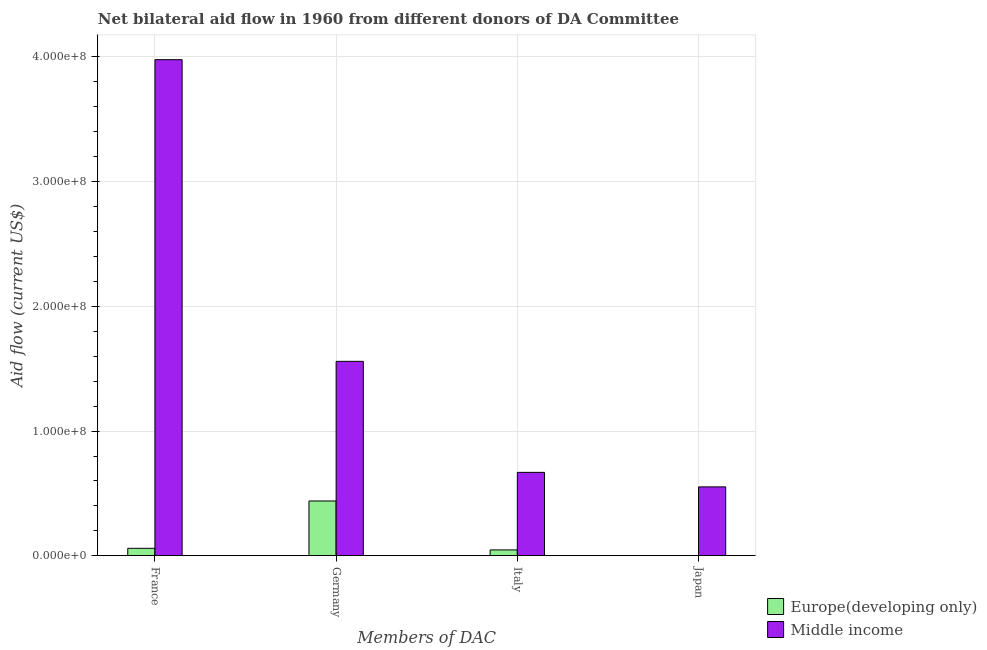How many different coloured bars are there?
Provide a short and direct response. 2. How many groups of bars are there?
Your answer should be compact. 4. Are the number of bars per tick equal to the number of legend labels?
Give a very brief answer. Yes. Are the number of bars on each tick of the X-axis equal?
Make the answer very short. Yes. What is the label of the 2nd group of bars from the left?
Provide a succinct answer. Germany. What is the amount of aid given by germany in Middle income?
Keep it short and to the point. 1.56e+08. Across all countries, what is the maximum amount of aid given by germany?
Ensure brevity in your answer.  1.56e+08. Across all countries, what is the minimum amount of aid given by italy?
Offer a very short reply. 4.71e+06. In which country was the amount of aid given by italy maximum?
Provide a succinct answer. Middle income. In which country was the amount of aid given by france minimum?
Provide a succinct answer. Europe(developing only). What is the total amount of aid given by japan in the graph?
Provide a succinct answer. 5.53e+07. What is the difference between the amount of aid given by france in Middle income and that in Europe(developing only)?
Your answer should be very brief. 3.92e+08. What is the difference between the amount of aid given by japan in Middle income and the amount of aid given by germany in Europe(developing only)?
Make the answer very short. 1.13e+07. What is the average amount of aid given by france per country?
Your answer should be very brief. 2.02e+08. What is the difference between the amount of aid given by italy and amount of aid given by france in Middle income?
Offer a terse response. -3.31e+08. What is the ratio of the amount of aid given by germany in Europe(developing only) to that in Middle income?
Your response must be concise. 0.28. What is the difference between the highest and the second highest amount of aid given by france?
Keep it short and to the point. 3.92e+08. What is the difference between the highest and the lowest amount of aid given by france?
Your answer should be compact. 3.92e+08. Is the sum of the amount of aid given by japan in Europe(developing only) and Middle income greater than the maximum amount of aid given by italy across all countries?
Your answer should be very brief. No. Is it the case that in every country, the sum of the amount of aid given by france and amount of aid given by italy is greater than the sum of amount of aid given by germany and amount of aid given by japan?
Make the answer very short. No. What does the 1st bar from the left in Italy represents?
Ensure brevity in your answer.  Europe(developing only). What does the 2nd bar from the right in Japan represents?
Your response must be concise. Europe(developing only). How many bars are there?
Offer a very short reply. 8. How many countries are there in the graph?
Offer a very short reply. 2. Are the values on the major ticks of Y-axis written in scientific E-notation?
Make the answer very short. Yes. Does the graph contain any zero values?
Give a very brief answer. No. Does the graph contain grids?
Offer a terse response. Yes. Where does the legend appear in the graph?
Your answer should be very brief. Bottom right. What is the title of the graph?
Give a very brief answer. Net bilateral aid flow in 1960 from different donors of DA Committee. What is the label or title of the X-axis?
Offer a very short reply. Members of DAC. What is the label or title of the Y-axis?
Offer a terse response. Aid flow (current US$). What is the Aid flow (current US$) of Europe(developing only) in France?
Make the answer very short. 6.00e+06. What is the Aid flow (current US$) of Middle income in France?
Make the answer very short. 3.98e+08. What is the Aid flow (current US$) of Europe(developing only) in Germany?
Ensure brevity in your answer.  4.40e+07. What is the Aid flow (current US$) of Middle income in Germany?
Give a very brief answer. 1.56e+08. What is the Aid flow (current US$) in Europe(developing only) in Italy?
Offer a terse response. 4.71e+06. What is the Aid flow (current US$) in Middle income in Italy?
Give a very brief answer. 6.69e+07. What is the Aid flow (current US$) in Europe(developing only) in Japan?
Give a very brief answer. 10000. What is the Aid flow (current US$) of Middle income in Japan?
Give a very brief answer. 5.53e+07. Across all Members of DAC, what is the maximum Aid flow (current US$) of Europe(developing only)?
Keep it short and to the point. 4.40e+07. Across all Members of DAC, what is the maximum Aid flow (current US$) of Middle income?
Your response must be concise. 3.98e+08. Across all Members of DAC, what is the minimum Aid flow (current US$) in Middle income?
Your response must be concise. 5.53e+07. What is the total Aid flow (current US$) in Europe(developing only) in the graph?
Your response must be concise. 5.47e+07. What is the total Aid flow (current US$) in Middle income in the graph?
Offer a very short reply. 6.76e+08. What is the difference between the Aid flow (current US$) of Europe(developing only) in France and that in Germany?
Give a very brief answer. -3.80e+07. What is the difference between the Aid flow (current US$) in Middle income in France and that in Germany?
Offer a very short reply. 2.42e+08. What is the difference between the Aid flow (current US$) in Europe(developing only) in France and that in Italy?
Ensure brevity in your answer.  1.29e+06. What is the difference between the Aid flow (current US$) in Middle income in France and that in Italy?
Ensure brevity in your answer.  3.31e+08. What is the difference between the Aid flow (current US$) in Europe(developing only) in France and that in Japan?
Your answer should be very brief. 5.99e+06. What is the difference between the Aid flow (current US$) of Middle income in France and that in Japan?
Provide a short and direct response. 3.43e+08. What is the difference between the Aid flow (current US$) in Europe(developing only) in Germany and that in Italy?
Offer a very short reply. 3.92e+07. What is the difference between the Aid flow (current US$) in Middle income in Germany and that in Italy?
Offer a very short reply. 8.90e+07. What is the difference between the Aid flow (current US$) in Europe(developing only) in Germany and that in Japan?
Ensure brevity in your answer.  4.40e+07. What is the difference between the Aid flow (current US$) in Middle income in Germany and that in Japan?
Make the answer very short. 1.01e+08. What is the difference between the Aid flow (current US$) in Europe(developing only) in Italy and that in Japan?
Your answer should be very brief. 4.70e+06. What is the difference between the Aid flow (current US$) in Middle income in Italy and that in Japan?
Make the answer very short. 1.16e+07. What is the difference between the Aid flow (current US$) of Europe(developing only) in France and the Aid flow (current US$) of Middle income in Germany?
Provide a succinct answer. -1.50e+08. What is the difference between the Aid flow (current US$) in Europe(developing only) in France and the Aid flow (current US$) in Middle income in Italy?
Provide a short and direct response. -6.09e+07. What is the difference between the Aid flow (current US$) in Europe(developing only) in France and the Aid flow (current US$) in Middle income in Japan?
Keep it short and to the point. -4.93e+07. What is the difference between the Aid flow (current US$) in Europe(developing only) in Germany and the Aid flow (current US$) in Middle income in Italy?
Your answer should be compact. -2.29e+07. What is the difference between the Aid flow (current US$) in Europe(developing only) in Germany and the Aid flow (current US$) in Middle income in Japan?
Your answer should be compact. -1.13e+07. What is the difference between the Aid flow (current US$) of Europe(developing only) in Italy and the Aid flow (current US$) of Middle income in Japan?
Provide a short and direct response. -5.06e+07. What is the average Aid flow (current US$) in Europe(developing only) per Members of DAC?
Make the answer very short. 1.37e+07. What is the average Aid flow (current US$) in Middle income per Members of DAC?
Your answer should be compact. 1.69e+08. What is the difference between the Aid flow (current US$) of Europe(developing only) and Aid flow (current US$) of Middle income in France?
Your answer should be compact. -3.92e+08. What is the difference between the Aid flow (current US$) of Europe(developing only) and Aid flow (current US$) of Middle income in Germany?
Give a very brief answer. -1.12e+08. What is the difference between the Aid flow (current US$) in Europe(developing only) and Aid flow (current US$) in Middle income in Italy?
Provide a short and direct response. -6.22e+07. What is the difference between the Aid flow (current US$) in Europe(developing only) and Aid flow (current US$) in Middle income in Japan?
Your answer should be very brief. -5.52e+07. What is the ratio of the Aid flow (current US$) in Europe(developing only) in France to that in Germany?
Keep it short and to the point. 0.14. What is the ratio of the Aid flow (current US$) in Middle income in France to that in Germany?
Ensure brevity in your answer.  2.55. What is the ratio of the Aid flow (current US$) of Europe(developing only) in France to that in Italy?
Provide a succinct answer. 1.27. What is the ratio of the Aid flow (current US$) in Middle income in France to that in Italy?
Your response must be concise. 5.95. What is the ratio of the Aid flow (current US$) of Europe(developing only) in France to that in Japan?
Your response must be concise. 600. What is the ratio of the Aid flow (current US$) of Middle income in France to that in Japan?
Provide a succinct answer. 7.2. What is the ratio of the Aid flow (current US$) in Europe(developing only) in Germany to that in Italy?
Make the answer very short. 9.33. What is the ratio of the Aid flow (current US$) in Middle income in Germany to that in Italy?
Your answer should be very brief. 2.33. What is the ratio of the Aid flow (current US$) in Europe(developing only) in Germany to that in Japan?
Your answer should be compact. 4396. What is the ratio of the Aid flow (current US$) of Middle income in Germany to that in Japan?
Provide a short and direct response. 2.82. What is the ratio of the Aid flow (current US$) in Europe(developing only) in Italy to that in Japan?
Give a very brief answer. 471. What is the ratio of the Aid flow (current US$) in Middle income in Italy to that in Japan?
Offer a very short reply. 1.21. What is the difference between the highest and the second highest Aid flow (current US$) of Europe(developing only)?
Keep it short and to the point. 3.80e+07. What is the difference between the highest and the second highest Aid flow (current US$) of Middle income?
Make the answer very short. 2.42e+08. What is the difference between the highest and the lowest Aid flow (current US$) in Europe(developing only)?
Offer a terse response. 4.40e+07. What is the difference between the highest and the lowest Aid flow (current US$) of Middle income?
Offer a very short reply. 3.43e+08. 